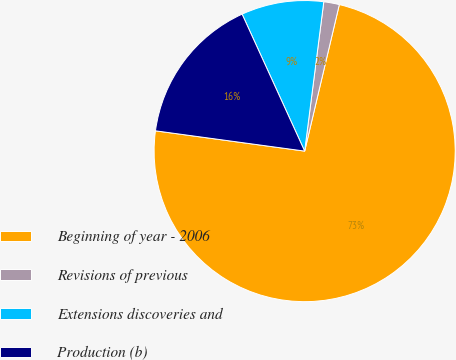Convert chart to OTSL. <chart><loc_0><loc_0><loc_500><loc_500><pie_chart><fcel>Beginning of year - 2006<fcel>Revisions of previous<fcel>Extensions discoveries and<fcel>Production (b)<nl><fcel>73.46%<fcel>1.67%<fcel>8.85%<fcel>16.03%<nl></chart> 